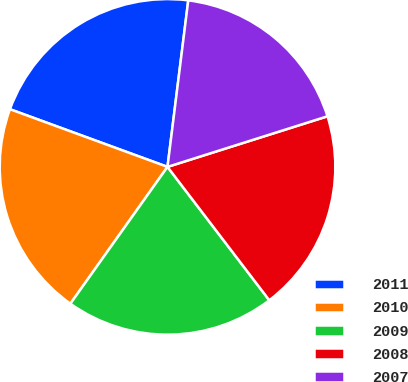Convert chart to OTSL. <chart><loc_0><loc_0><loc_500><loc_500><pie_chart><fcel>2011<fcel>2010<fcel>2009<fcel>2008<fcel>2007<nl><fcel>21.39%<fcel>20.76%<fcel>20.2%<fcel>19.5%<fcel>18.15%<nl></chart> 